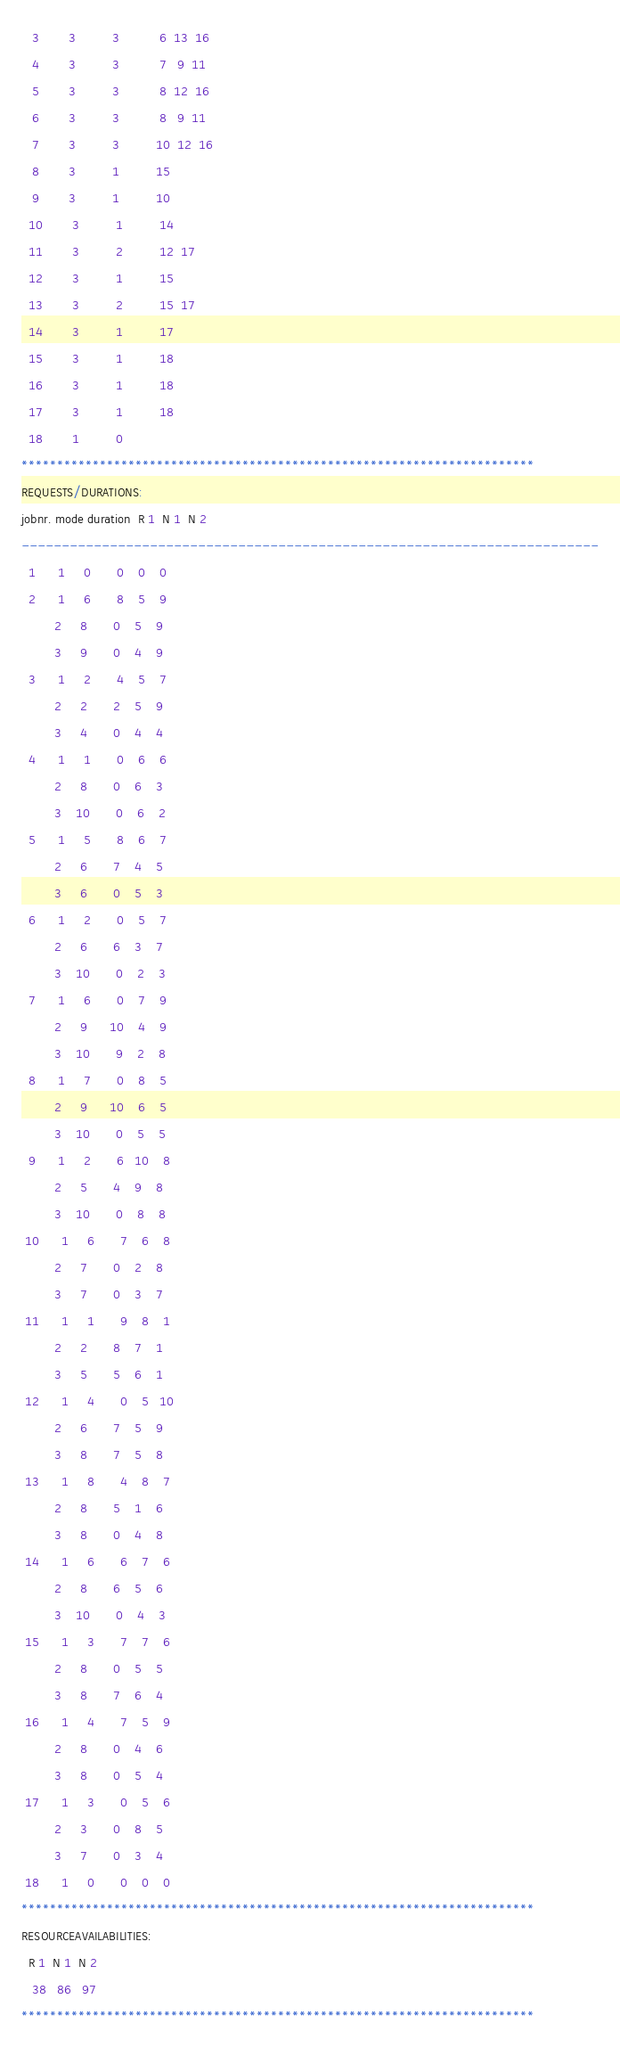<code> <loc_0><loc_0><loc_500><loc_500><_ObjectiveC_>   3        3          3           6  13  16
   4        3          3           7   9  11
   5        3          3           8  12  16
   6        3          3           8   9  11
   7        3          3          10  12  16
   8        3          1          15
   9        3          1          10
  10        3          1          14
  11        3          2          12  17
  12        3          1          15
  13        3          2          15  17
  14        3          1          17
  15        3          1          18
  16        3          1          18
  17        3          1          18
  18        1          0        
************************************************************************
REQUESTS/DURATIONS:
jobnr. mode duration  R 1  N 1  N 2
------------------------------------------------------------------------
  1      1     0       0    0    0
  2      1     6       8    5    9
         2     8       0    5    9
         3     9       0    4    9
  3      1     2       4    5    7
         2     2       2    5    9
         3     4       0    4    4
  4      1     1       0    6    6
         2     8       0    6    3
         3    10       0    6    2
  5      1     5       8    6    7
         2     6       7    4    5
         3     6       0    5    3
  6      1     2       0    5    7
         2     6       6    3    7
         3    10       0    2    3
  7      1     6       0    7    9
         2     9      10    4    9
         3    10       9    2    8
  8      1     7       0    8    5
         2     9      10    6    5
         3    10       0    5    5
  9      1     2       6   10    8
         2     5       4    9    8
         3    10       0    8    8
 10      1     6       7    6    8
         2     7       0    2    8
         3     7       0    3    7
 11      1     1       9    8    1
         2     2       8    7    1
         3     5       5    6    1
 12      1     4       0    5   10
         2     6       7    5    9
         3     8       7    5    8
 13      1     8       4    8    7
         2     8       5    1    6
         3     8       0    4    8
 14      1     6       6    7    6
         2     8       6    5    6
         3    10       0    4    3
 15      1     3       7    7    6
         2     8       0    5    5
         3     8       7    6    4
 16      1     4       7    5    9
         2     8       0    4    6
         3     8       0    5    4
 17      1     3       0    5    6
         2     3       0    8    5
         3     7       0    3    4
 18      1     0       0    0    0
************************************************************************
RESOURCEAVAILABILITIES:
  R 1  N 1  N 2
   38   86   97
************************************************************************
</code> 